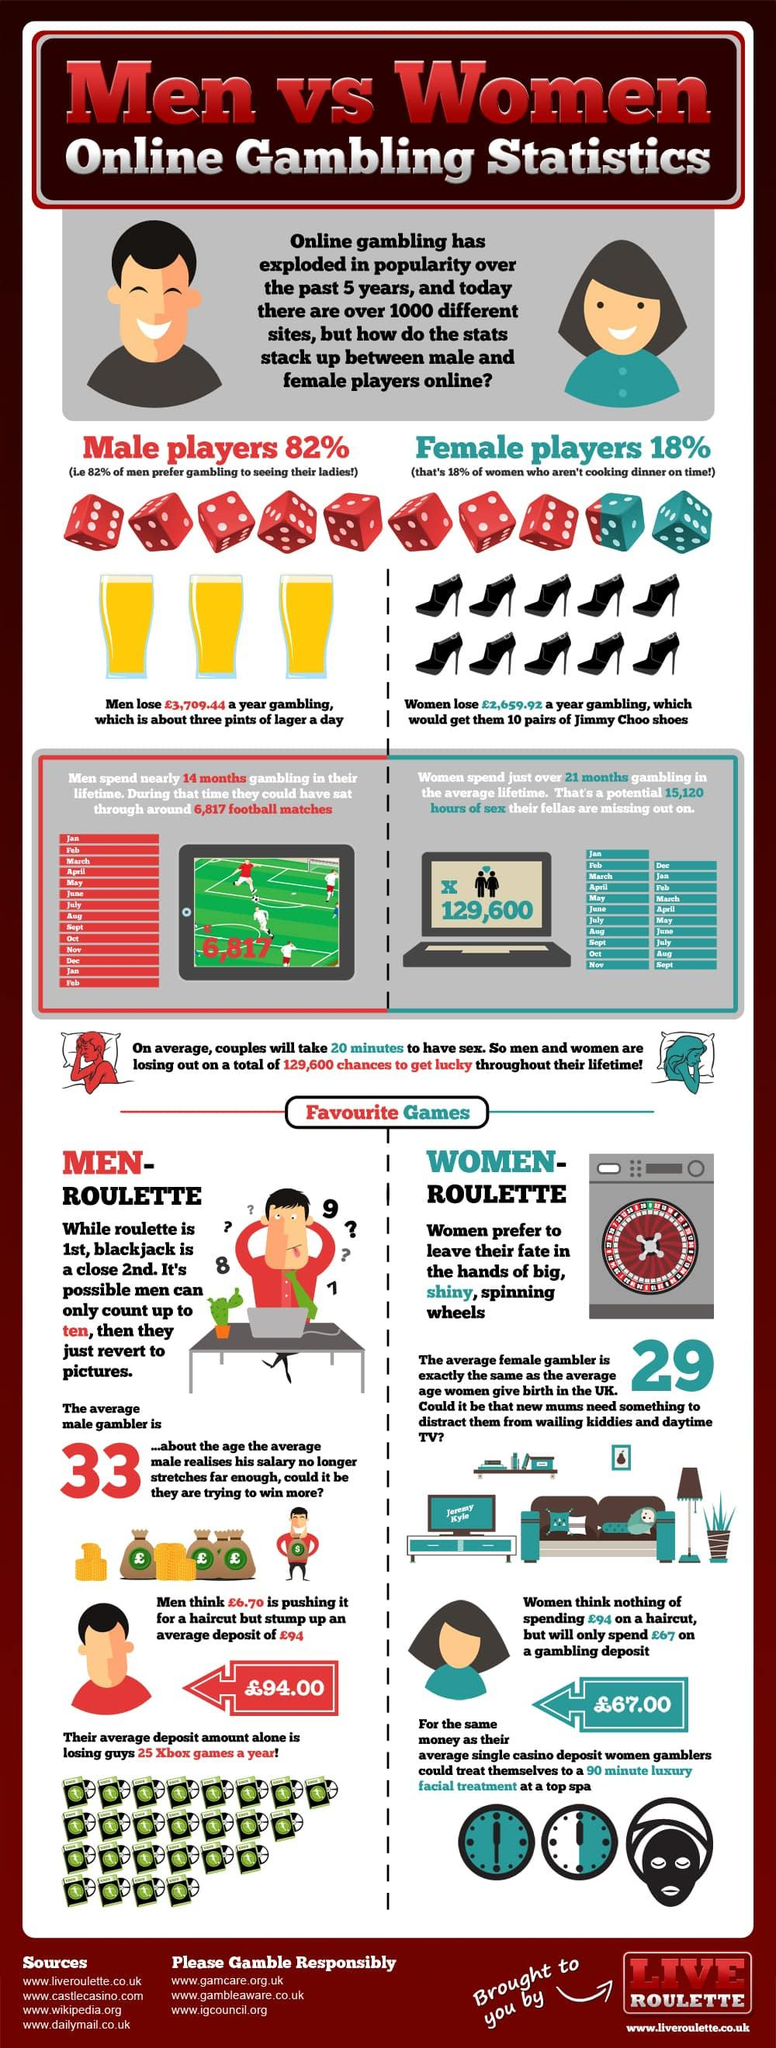Specify some key components in this picture. This infographic contains two clocks. There are ten dice in this infographic. 